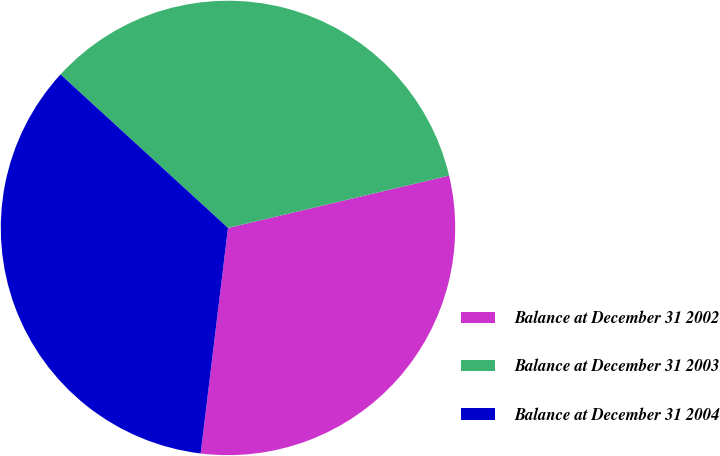Convert chart. <chart><loc_0><loc_0><loc_500><loc_500><pie_chart><fcel>Balance at December 31 2002<fcel>Balance at December 31 2003<fcel>Balance at December 31 2004<nl><fcel>30.62%<fcel>34.5%<fcel>34.89%<nl></chart> 